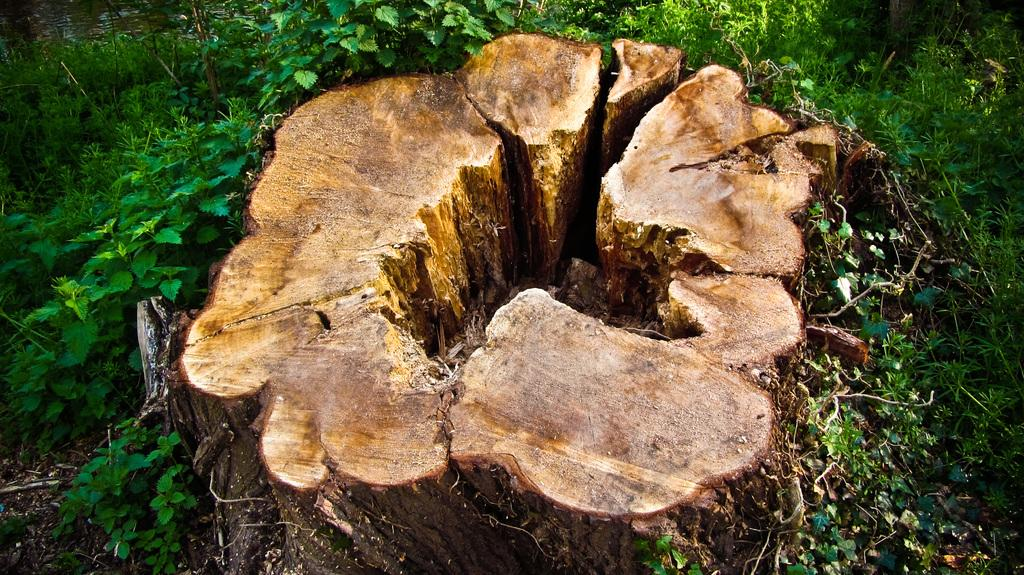What is the main subject in the center of the image? There is a tree trunk in the center of the image. What can be seen in the background of the image? There are plants in the background of the image. What is visible at the top of the image? There is water visible at the top of the image. What type of sand can be seen on the beach in the image? There is no beach or sand present in the image; it features a tree trunk, plants, and water. 